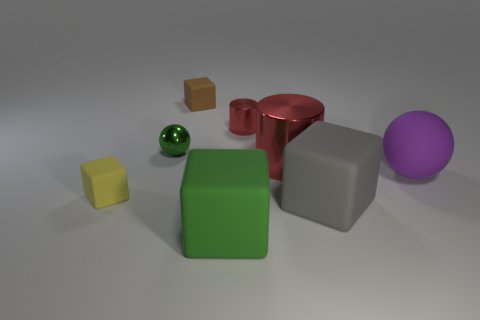Subtract all brown cubes. How many cubes are left? 3 Subtract all gray cubes. How many cubes are left? 3 Subtract 2 blocks. How many blocks are left? 2 Add 2 large green cubes. How many objects exist? 10 Subtract all purple cubes. Subtract all gray cylinders. How many cubes are left? 4 Subtract all cylinders. How many objects are left? 6 Add 1 tiny balls. How many tiny balls exist? 2 Subtract 1 green spheres. How many objects are left? 7 Subtract all red rubber cubes. Subtract all brown cubes. How many objects are left? 7 Add 1 small red metallic things. How many small red metallic things are left? 2 